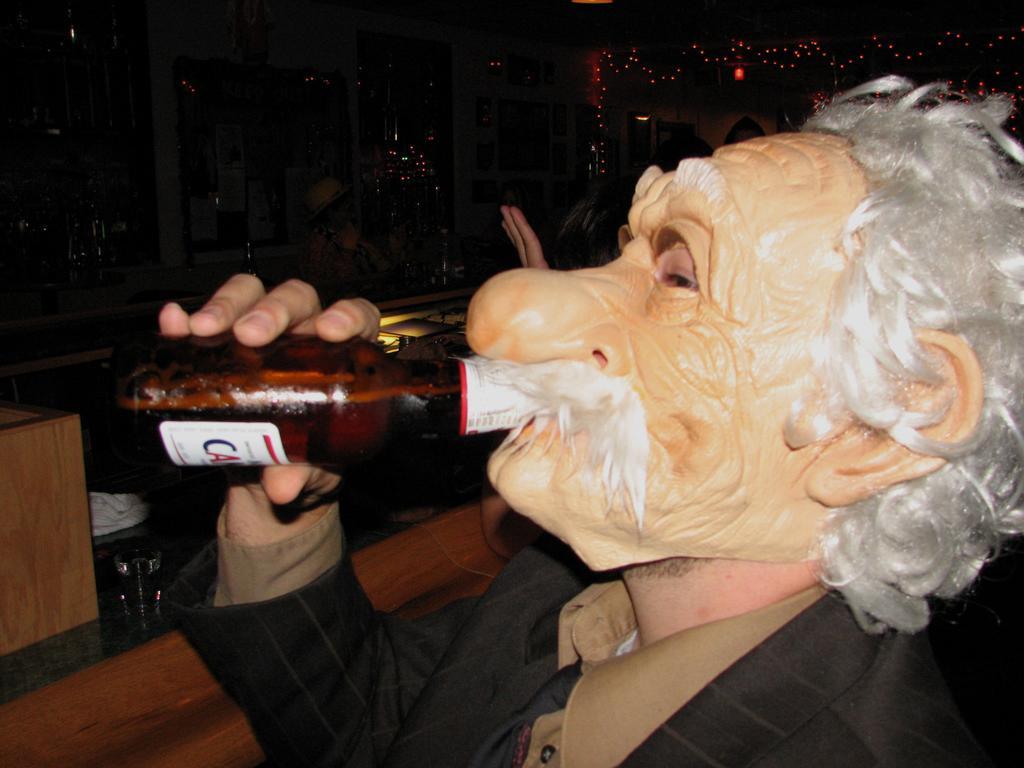Describe this image in one or two sentences. In this image we can see a man wearing a face mask on his face and he is drinking a beer. 